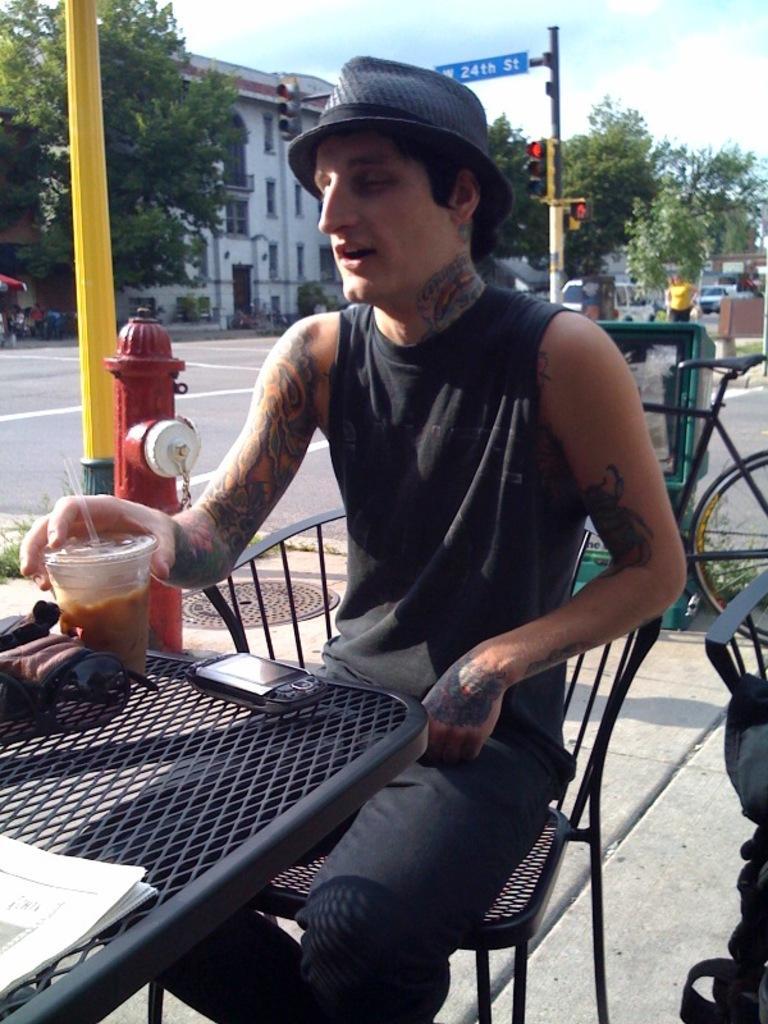Can you describe this image briefly? In this picture we can see a man wore a cap, sitting on a chair and in front of him we can see a mobile, glass, papers on the table and at the back of him we can see a bicycle, hydrant, name board, poles, traffic signals, trees, vehicles on the road, building with windows and some objects and in the background we can see the sky. 